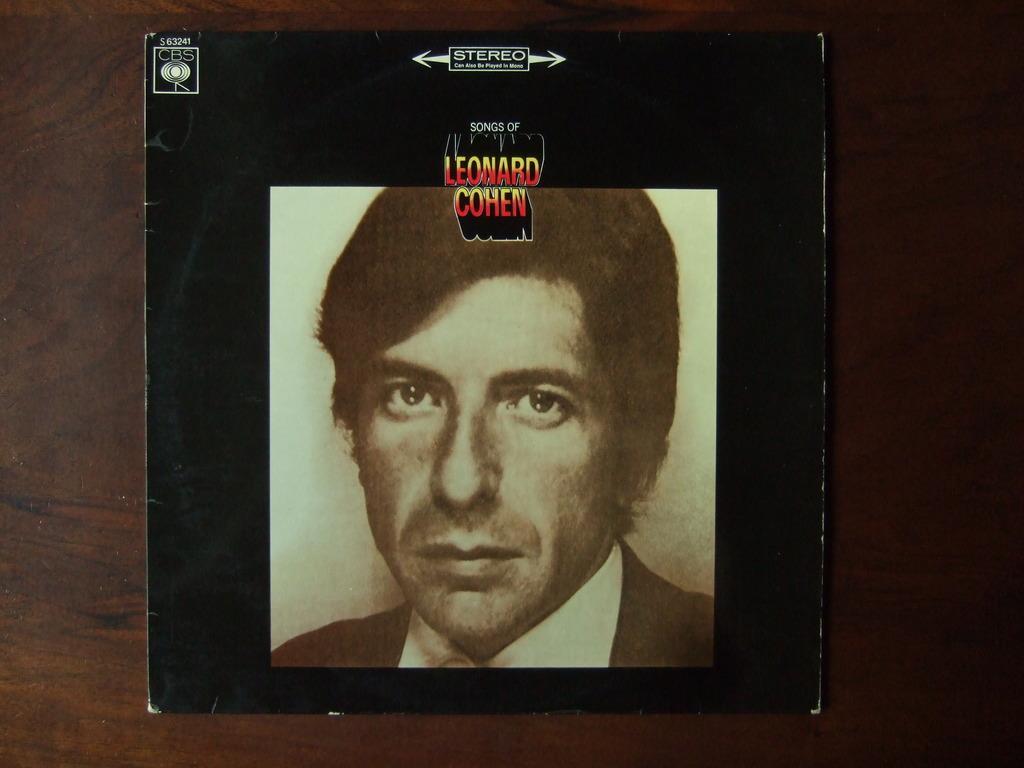How would you summarize this image in a sentence or two? In this image there is a photo of a man on the table. 